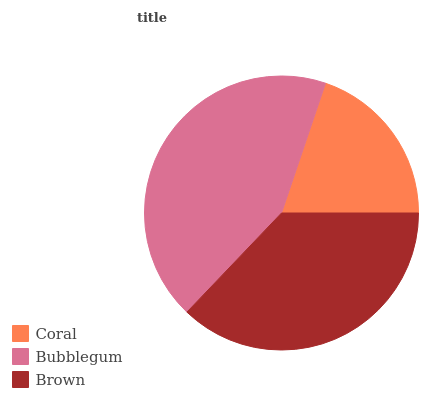Is Coral the minimum?
Answer yes or no. Yes. Is Bubblegum the maximum?
Answer yes or no. Yes. Is Brown the minimum?
Answer yes or no. No. Is Brown the maximum?
Answer yes or no. No. Is Bubblegum greater than Brown?
Answer yes or no. Yes. Is Brown less than Bubblegum?
Answer yes or no. Yes. Is Brown greater than Bubblegum?
Answer yes or no. No. Is Bubblegum less than Brown?
Answer yes or no. No. Is Brown the high median?
Answer yes or no. Yes. Is Brown the low median?
Answer yes or no. Yes. Is Bubblegum the high median?
Answer yes or no. No. Is Bubblegum the low median?
Answer yes or no. No. 